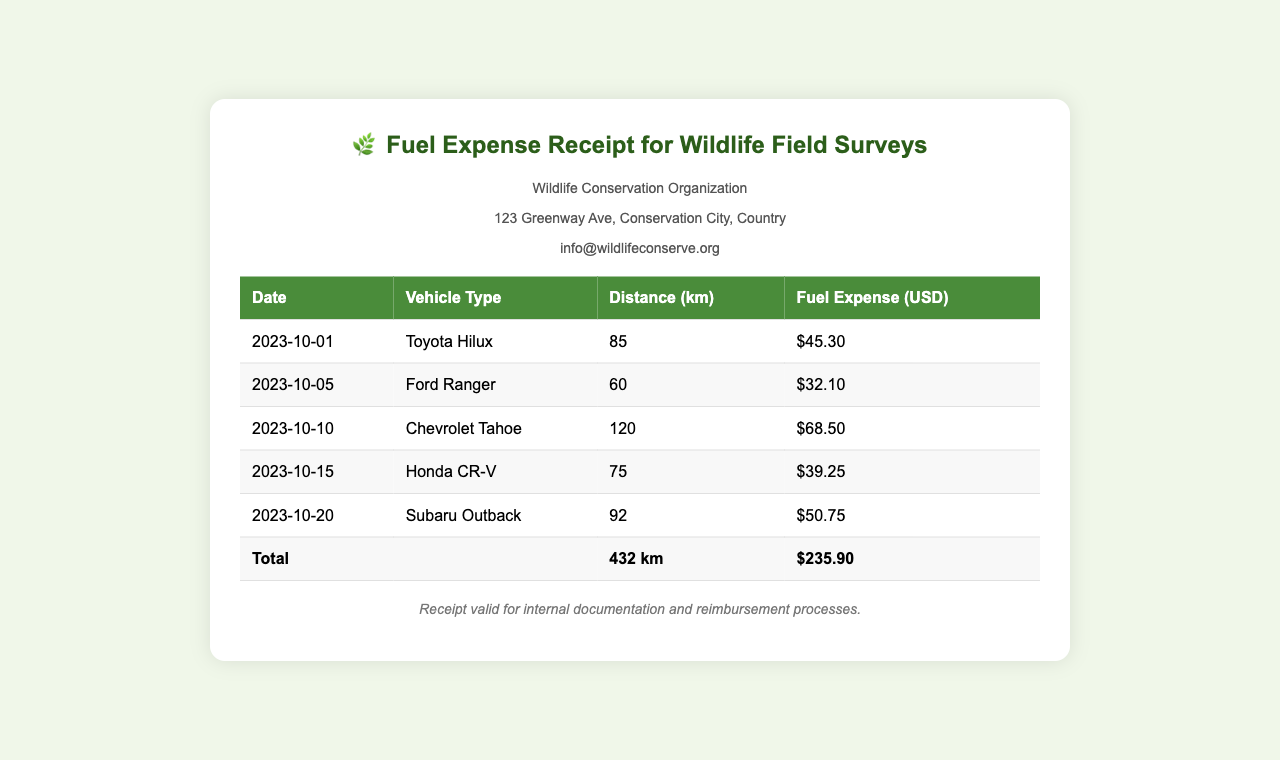What is the date of the first recorded fuel expense? The first fuel expense is recorded on October 1, 2023.
Answer: 2023-10-01 How much was spent on the Chevrolet Tahoe? The expense for the Chevrolet Tahoe is listed as $68.50.
Answer: $68.50 What was the total distance traveled for all field surveys? The total distance is computed from the sum of all individual distances, which equals 432 km.
Answer: 432 km Which vehicle type had the highest fuel expense? The Chevrolet Tahoe has the highest fuel expense at $68.50.
Answer: Chevrolet Tahoe On what date was the Ford Ranger used for field surveys? The Ford Ranger was used on October 5, 2023.
Answer: 2023-10-05 What is the total fuel expense for the field surveys? The fuel expenses from all entries sum up to $235.90.
Answer: $235.90 How many kilometers were traveled using the Honda CR-V? The distance traveled using the Honda CR-V is recorded as 75 km.
Answer: 75 km What is the purpose of this receipt? The receipt is for internal documentation and reimbursement processes related to wildlife field surveys.
Answer: internal documentation and reimbursement processes 